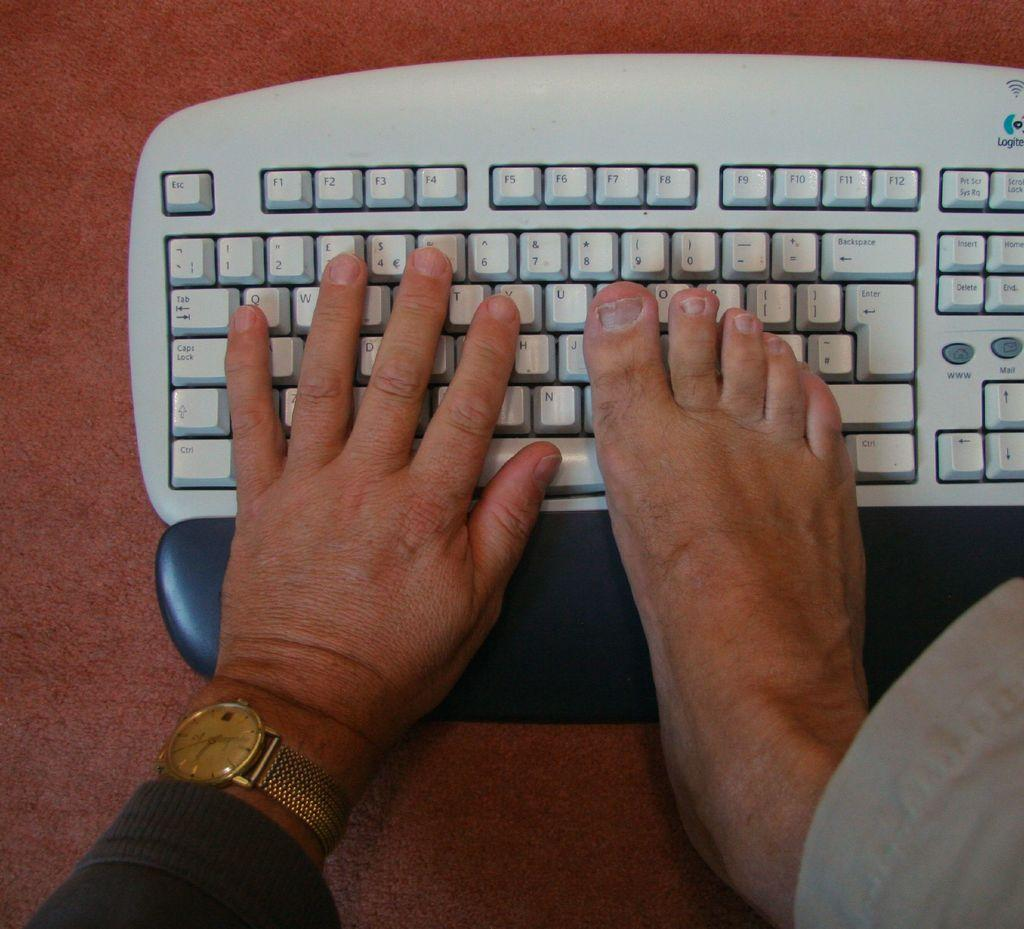<image>
Create a compact narrative representing the image presented. A person’s hand and foot are on a Logitech keyboard. 